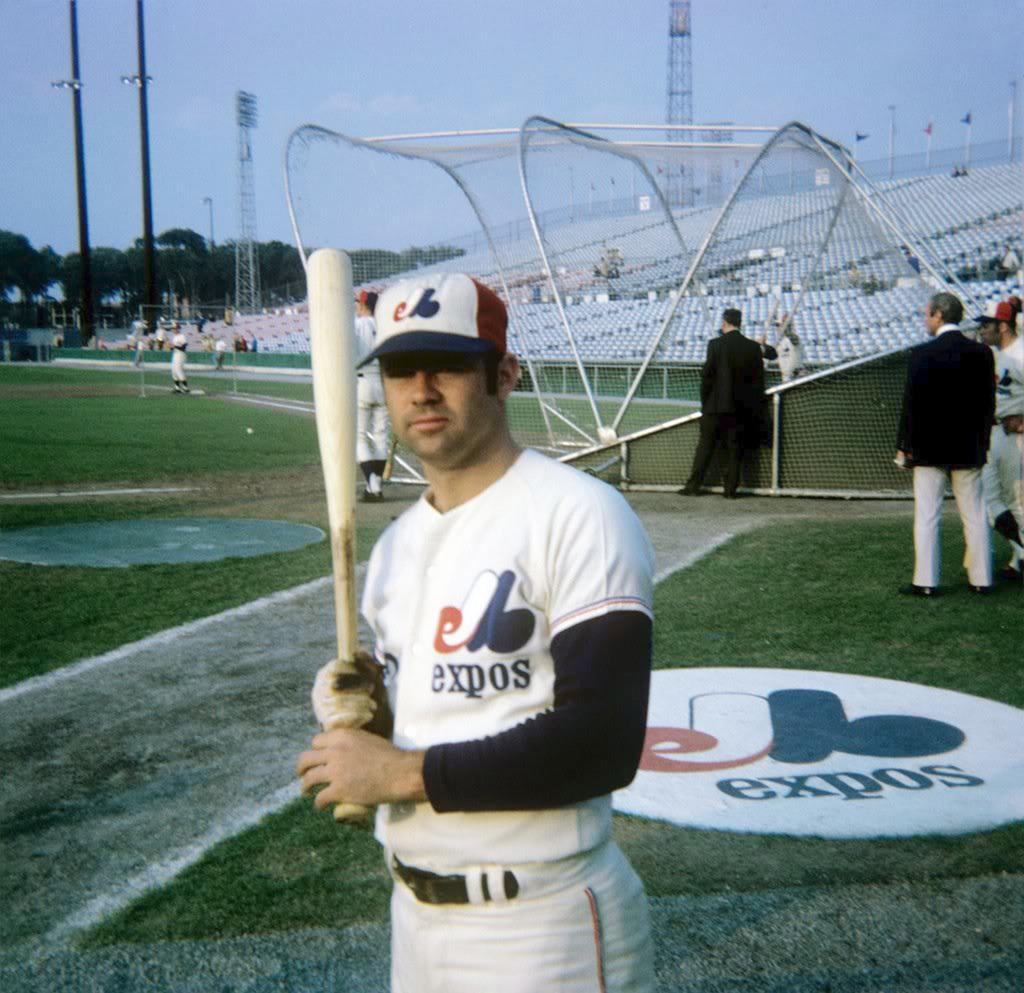<image>
Share a concise interpretation of the image provided. A baseball player with an Expos uniform poses with a bat on the side of the field. 